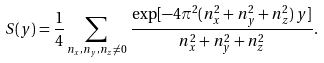Convert formula to latex. <formula><loc_0><loc_0><loc_500><loc_500>S ( y ) = \frac { 1 } { 4 } \sum _ { n _ { x } , n _ { y } , n _ { z } \neq 0 } \, \frac { \exp [ - 4 \pi ^ { 2 } ( n _ { x } ^ { 2 } + n _ { y } ^ { 2 } + n _ { z } ^ { 2 } ) \, y ] } { n _ { x } ^ { 2 } + n _ { y } ^ { 2 } + n _ { z } ^ { 2 } } .</formula> 